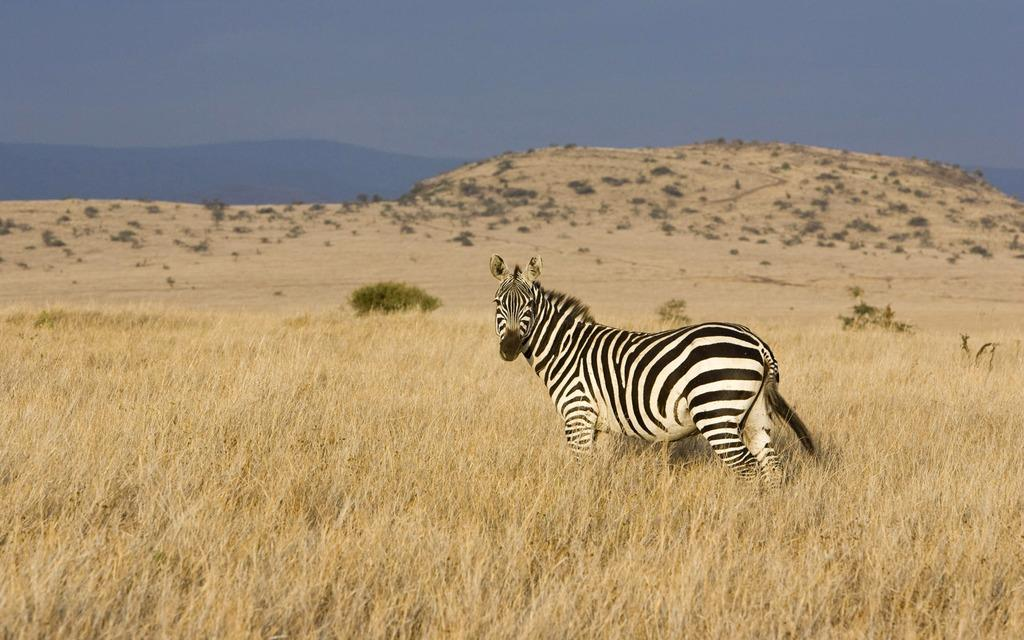What animal is present in the image? There is a giraffe in the image. What is the giraffe standing on? The giraffe is standing on the grass. What can be seen in the distance in the image? There are mountains in the background of the image. What else is visible in the background of the image? The sky is visible in the background of the image. Where can the beggar be found in the image? There is no beggar present in the image. What type of books can be seen on the giraffe's back? There are no books visible in the image, as it features a giraffe standing on grass with mountains and sky in the background. 